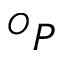Convert formula to latex. <formula><loc_0><loc_0><loc_500><loc_500>^ { O } P</formula> 